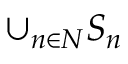Convert formula to latex. <formula><loc_0><loc_0><loc_500><loc_500>\cup _ { n \in N } S _ { n }</formula> 